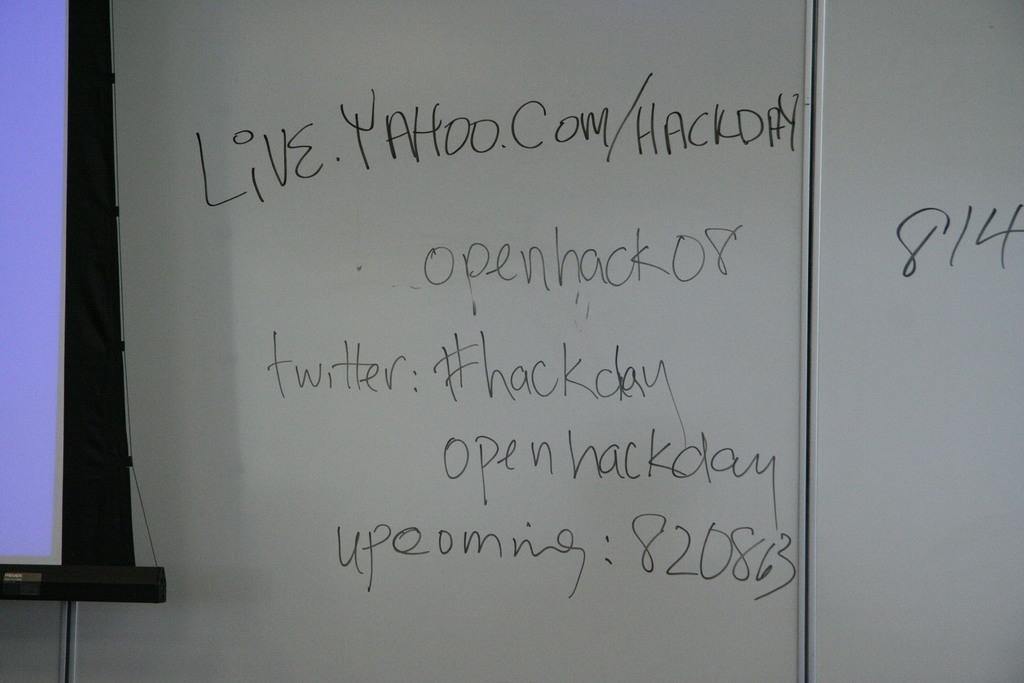<image>
Give a short and clear explanation of the subsequent image. A white board with the web address live.yahoo.com/hackday written on it. 